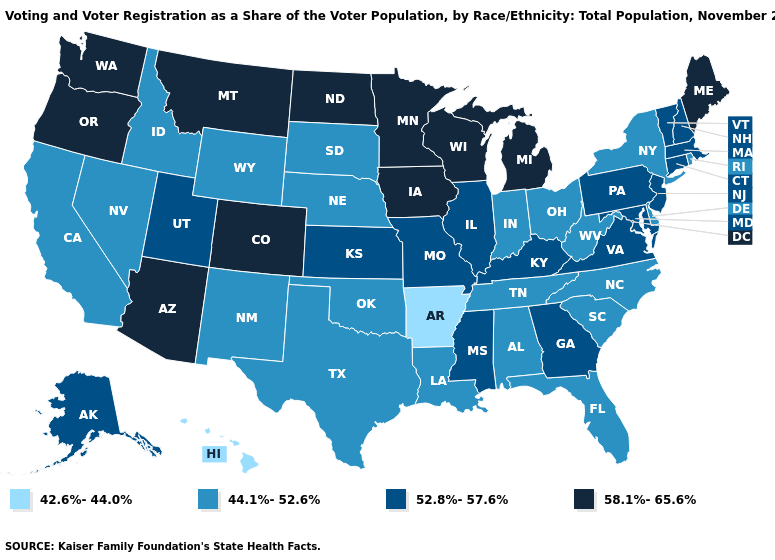Which states hav the highest value in the South?
Quick response, please. Georgia, Kentucky, Maryland, Mississippi, Virginia. What is the highest value in the Northeast ?
Write a very short answer. 58.1%-65.6%. Does Hawaii have the lowest value in the USA?
Short answer required. Yes. Does Texas have the same value as Illinois?
Quick response, please. No. Name the states that have a value in the range 42.6%-44.0%?
Concise answer only. Arkansas, Hawaii. What is the lowest value in the USA?
Answer briefly. 42.6%-44.0%. What is the lowest value in the USA?
Quick response, please. 42.6%-44.0%. Among the states that border California , does Nevada have the highest value?
Keep it brief. No. Among the states that border Iowa , does Wisconsin have the highest value?
Concise answer only. Yes. What is the value of Maryland?
Keep it brief. 52.8%-57.6%. Does Rhode Island have the same value as Illinois?
Short answer required. No. What is the value of Washington?
Concise answer only. 58.1%-65.6%. What is the value of Kentucky?
Concise answer only. 52.8%-57.6%. What is the value of Pennsylvania?
Keep it brief. 52.8%-57.6%. Among the states that border New Mexico , which have the highest value?
Write a very short answer. Arizona, Colorado. 